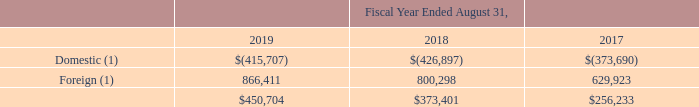4. Income Taxes
Provision for Income Taxes
Income (loss) before income tax expense is summarized below (in thousands):
(1) Includes the elimination of intercompany foreign dividends paid to the U.S.
What types of income (loss) before income tax expense is provided by the table? Domestic, foreign. What was the Domestic income (loss) in 2019?
Answer scale should be: thousand. $(415,707). What was the foreign income (loss) in 2018?
Answer scale should be: thousand. 800,298. What was the change in Foreign income (loss) between 2018 and 2019?
Answer scale should be: thousand. 866,411-800,298
Answer: 66113. How many years did Foreign income (loss) exceed $800,000 thousand? 2019##2018
Answer: 2. What was the percentage change in total income (loss) between 2017 and 2018?
Answer scale should be: percent. ($373,401-$256,233)/$256,233
Answer: 45.73. 